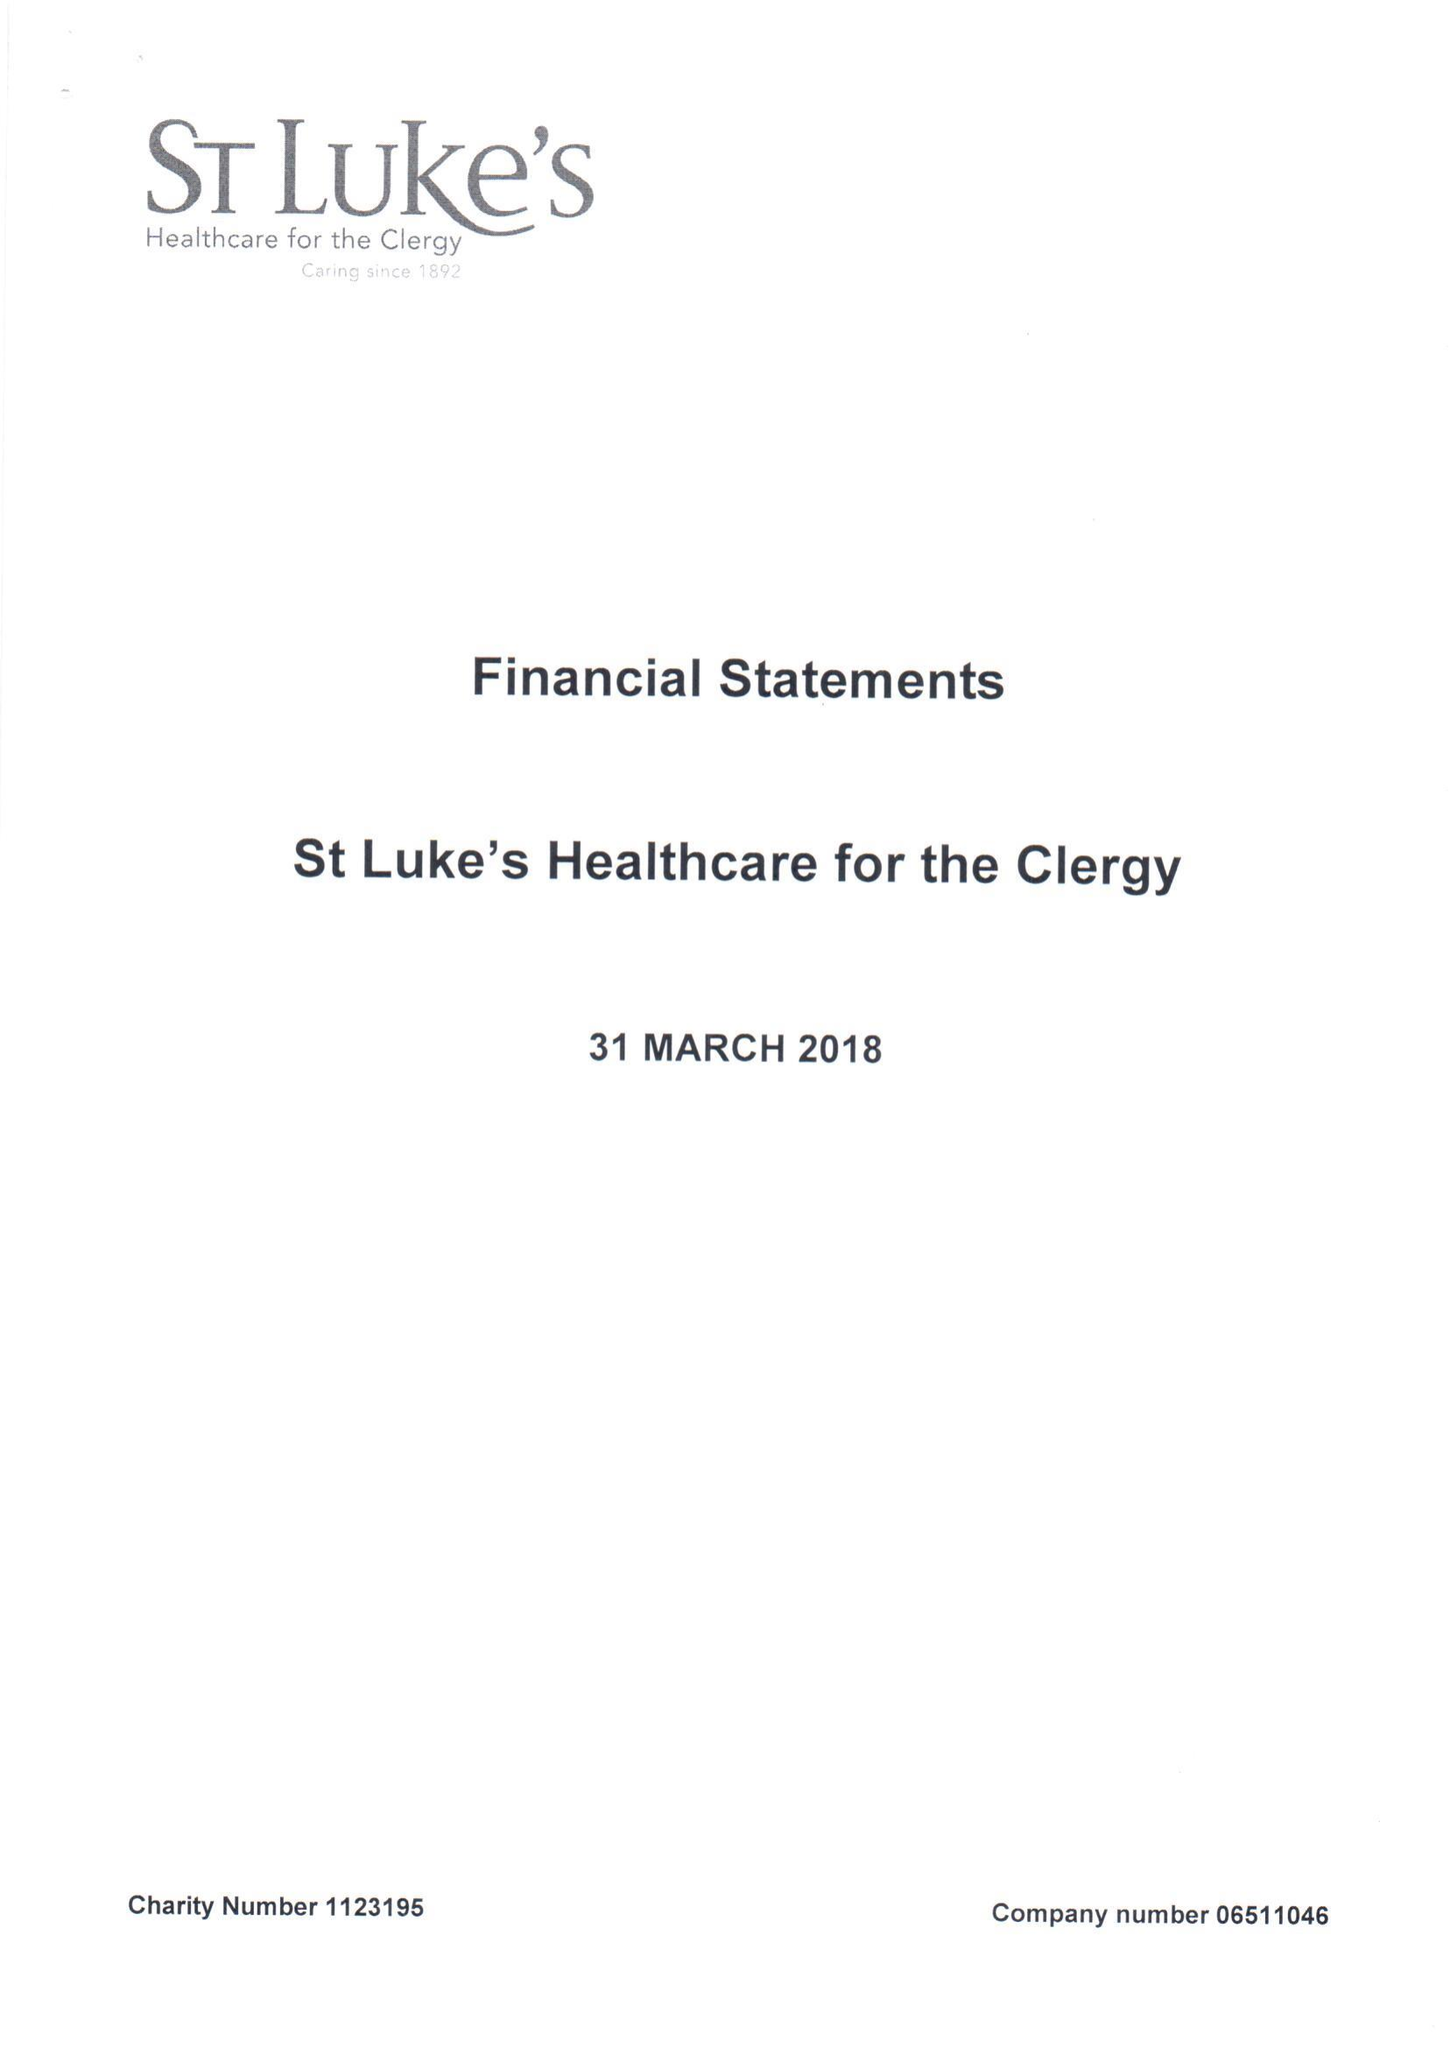What is the value for the charity_number?
Answer the question using a single word or phrase. 1123195 